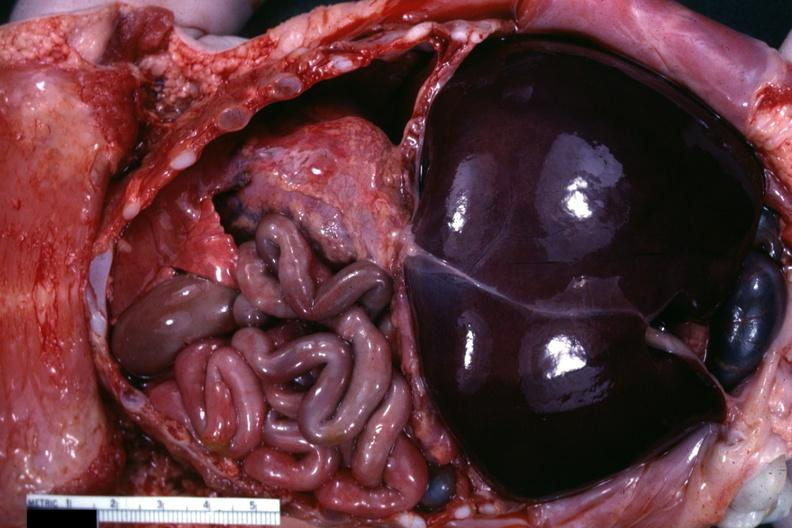what does this image show?
Answer the question using a single word or phrase. Opened body typical 